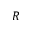Convert formula to latex. <formula><loc_0><loc_0><loc_500><loc_500>R</formula> 